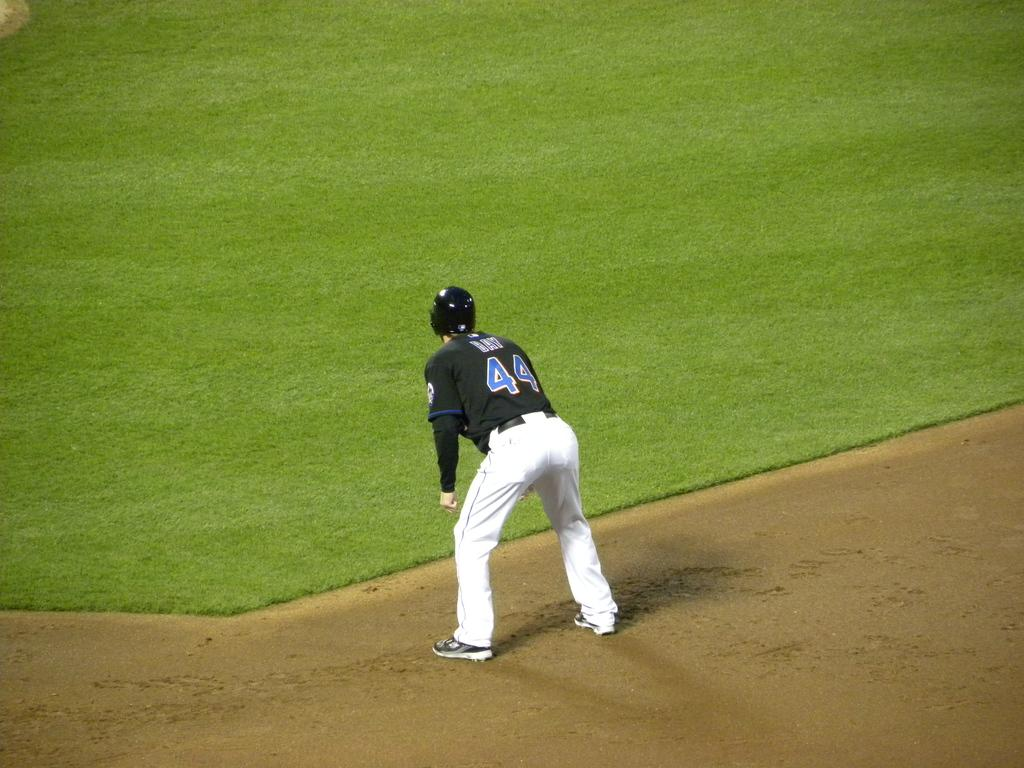<image>
Summarize the visual content of the image. Player number 44 crouches and looks across the field. 